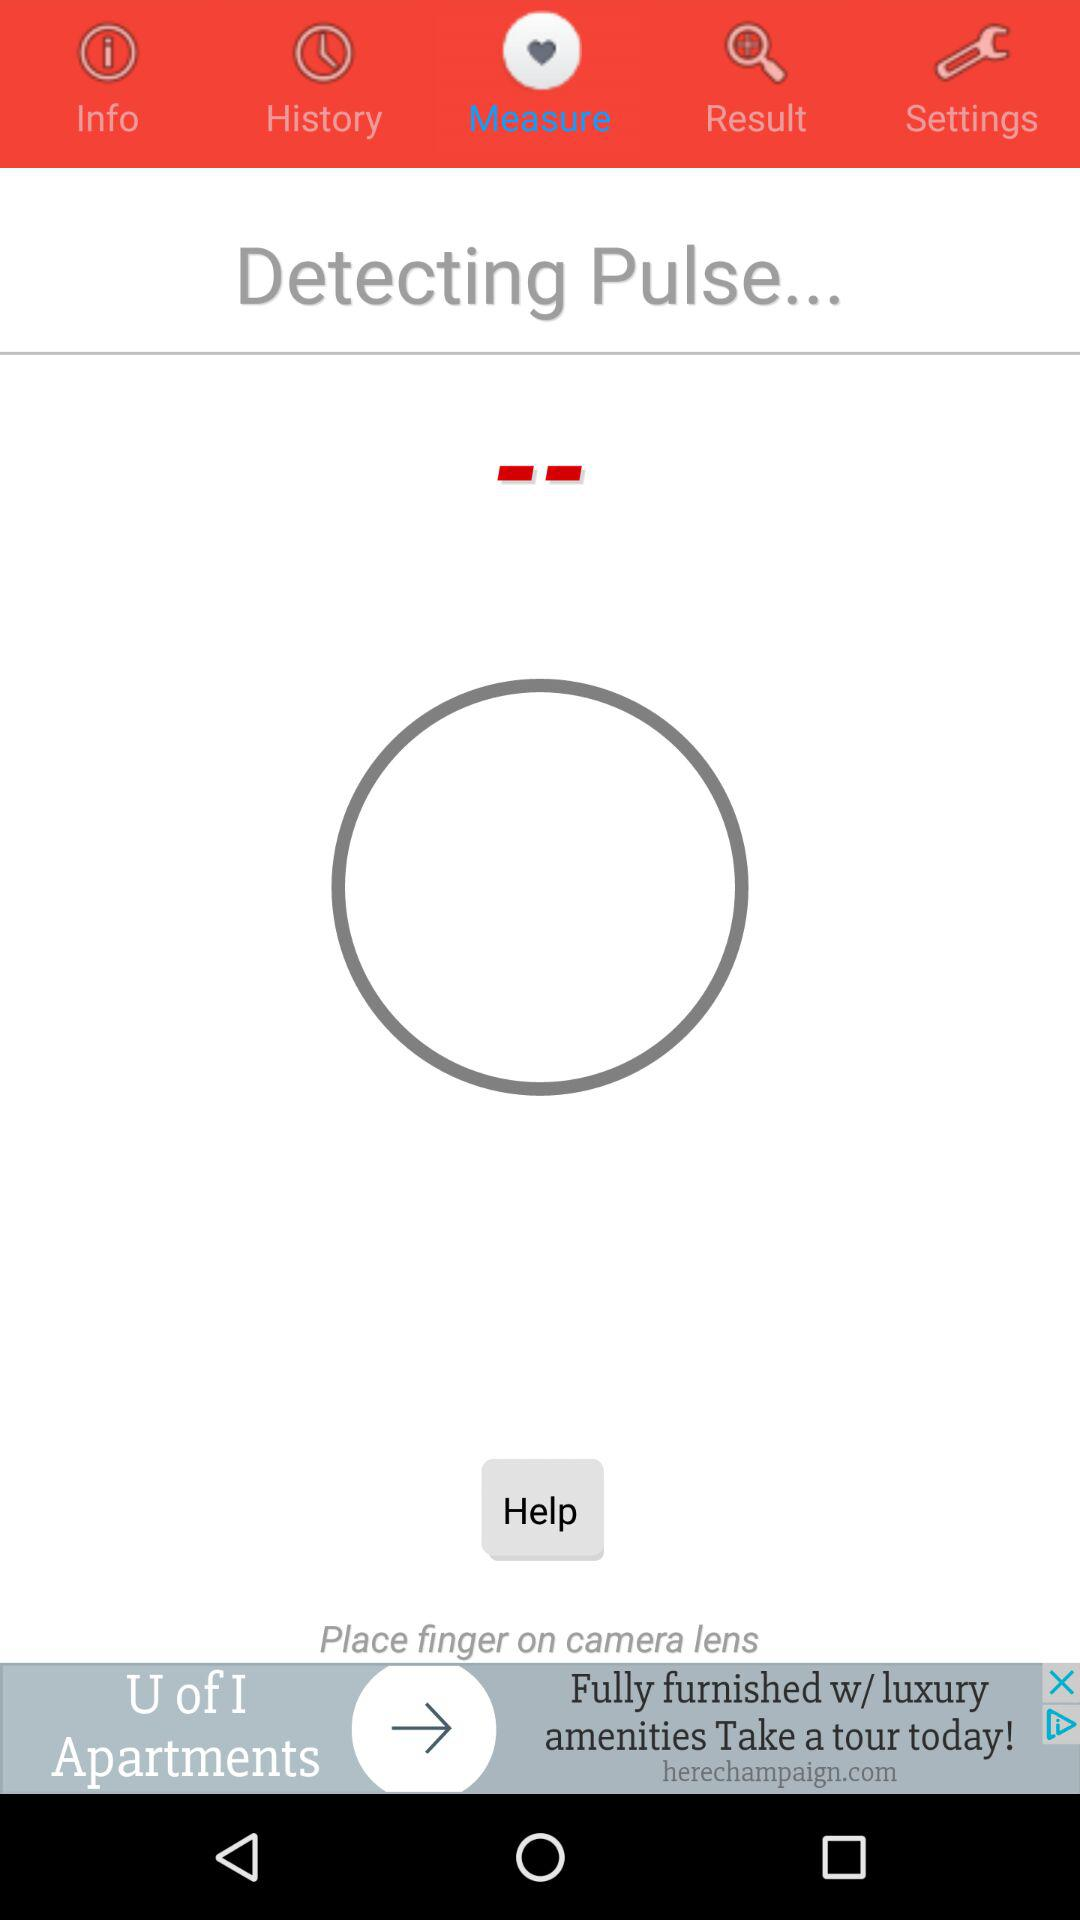What is the selected tab? The selected tab is "Measure". 